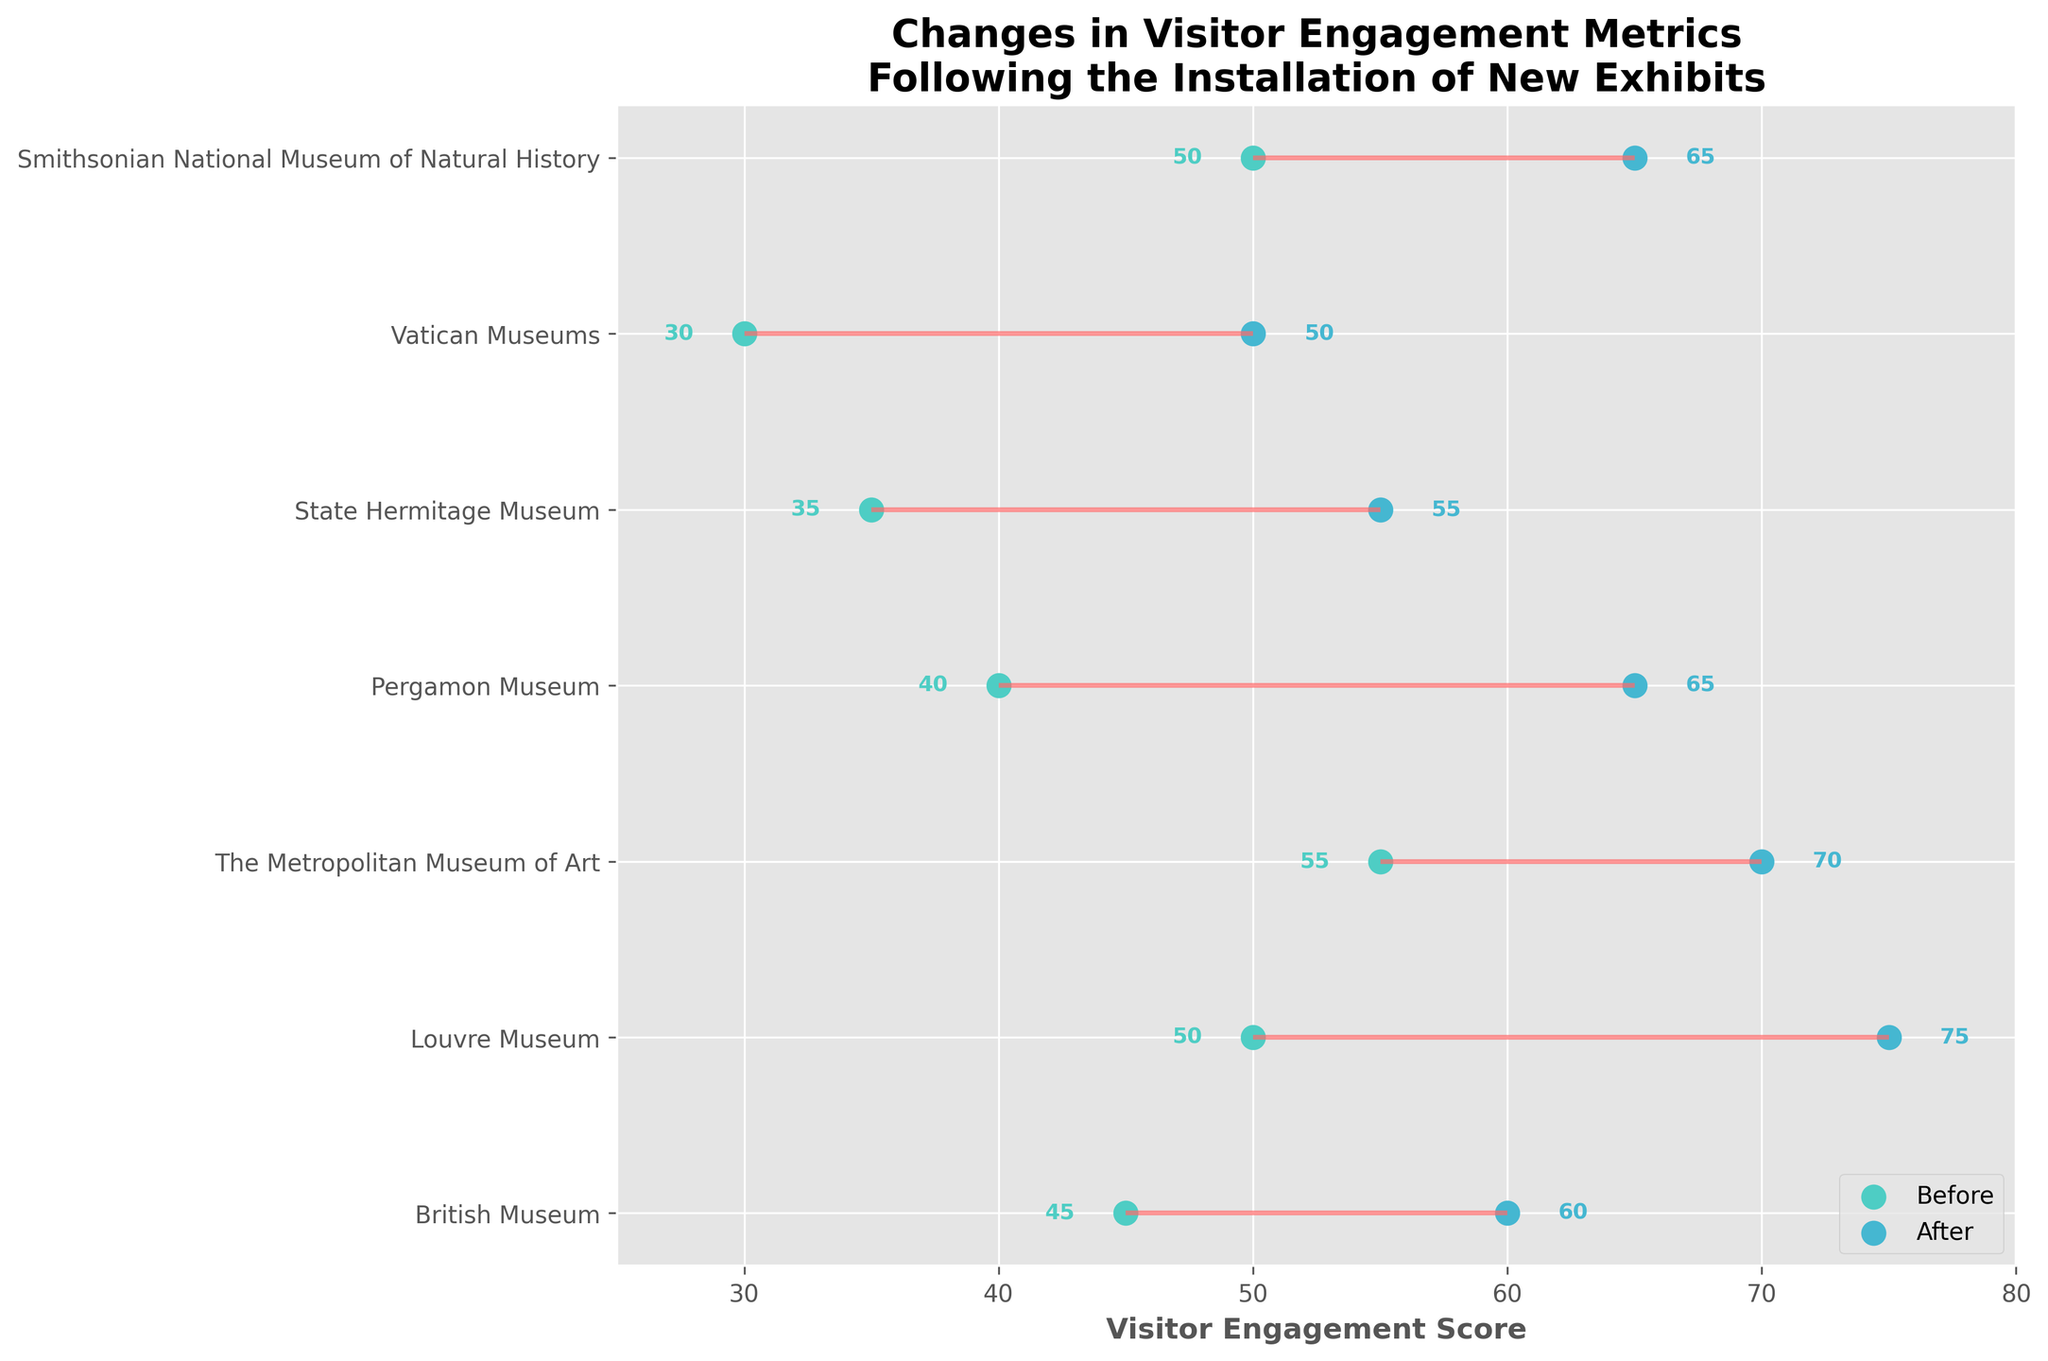What are the names of the museums included in the plot? The figure features the names of the museums on the y-axis. Observing the labels, the museums included are British Museum, Louvre Museum, The Metropolitan Museum of Art, Pergamon Museum, State Hermitage Museum, Vatican Museums, and Smithsonian National Museum of Natural History.
Answer: British Museum, Louvre Museum, The Metropolitan Museum of Art, Pergamon Museum, State Hermitage Museum, Vatican Museums, Smithsonian National Museum of Natural History How does visitor engagement at the Louvre Museum change after the new exhibit? The dumbbell plot shows the visitor engagement scores before and after installing the new exhibit. The score for the Louvre Museum increases from 50 to 75.
Answer: Increases from 50 to 75 Which museum had the highest visitor engagement before the new exhibit installation? By looking at the leftmost points for each dumbbell representing before values, The Metropolitan Museum of Art had the highest visitor engagement with a score of 55.
Answer: The Metropolitan Museum of Art What is the difference in visitor engagement before and after the new exhibit for the Pergamon Museum? The plot shows the Pergamon Museum's scores before and after the exhibit, which are 40 and 65, respectively. The difference is 65 - 40 = 25.
Answer: 25 What is the average visitor engagement score after the new exhibits were installed for all museums? The plot provides the "after" scores for each museum: 60, 75, 70, 65, 55, 50, 65. Adding these values, we get 440. Dividing by the number of museums (7), we get 440 / 7 ≈ 62.86.
Answer: 62.86 Which museum showed the greatest improvement in visitor engagement? To find the greatest improvement, compare the differences between before and after scores for all museums. The Louvre Museum improved from 50 to 75, an increase of 25, which is the highest observed improvement.
Answer: Louvre Museum What color represents the engagement scores before the new exhibits? The color of the dots on the left side (before the new exhibits) is a light teal.
Answer: Light teal How many museums have a visitor engagement score that increased by at least 15 points after the new exhibits? Calculate the differences for each museum: British Museum (15), Louvre Museum (25), Metropolitan Museum of Art (15), Pergamon Museum (25), State Hermitage Museum (20), Vatican Museums (20), Smithsonian National Museum (15). There are 7 museums with increases of at least 15 points.
Answer: 7 Which museum had the smallest change in visitor engagement after the new exhibit? The smallest change is calculated by observing the difference between before and after: British Museum (15), Louvre Museum (25), Metropolitan Museum of Art (15), Pergamon Museum (25), State Hermitage Museum (20), Vatican Museums (20), Smithsonian National Museum (15). The smallest changes are 15, shared by British Museum, Metropolitan Museum of Art, and Smithsonian National Museum.
Answer: British Museum, The Metropolitan Museum of Art, Smithsonian National Museum of Natural History 